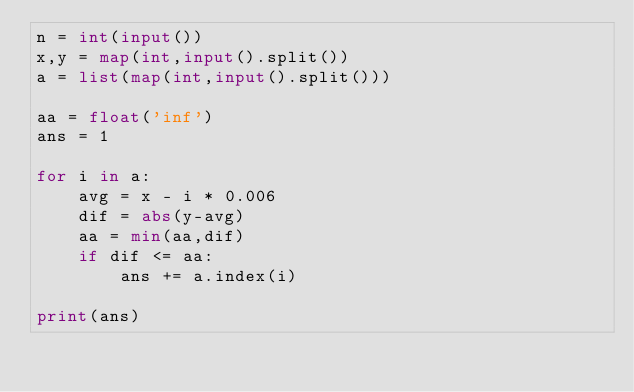Convert code to text. <code><loc_0><loc_0><loc_500><loc_500><_Python_>n = int(input())
x,y = map(int,input().split())
a = list(map(int,input().split()))

aa = float('inf')
ans = 1

for i in a:
    avg = x - i * 0.006
    dif = abs(y-avg)
    aa = min(aa,dif)
    if dif <= aa:
        ans += a.index(i)
        
print(ans)</code> 